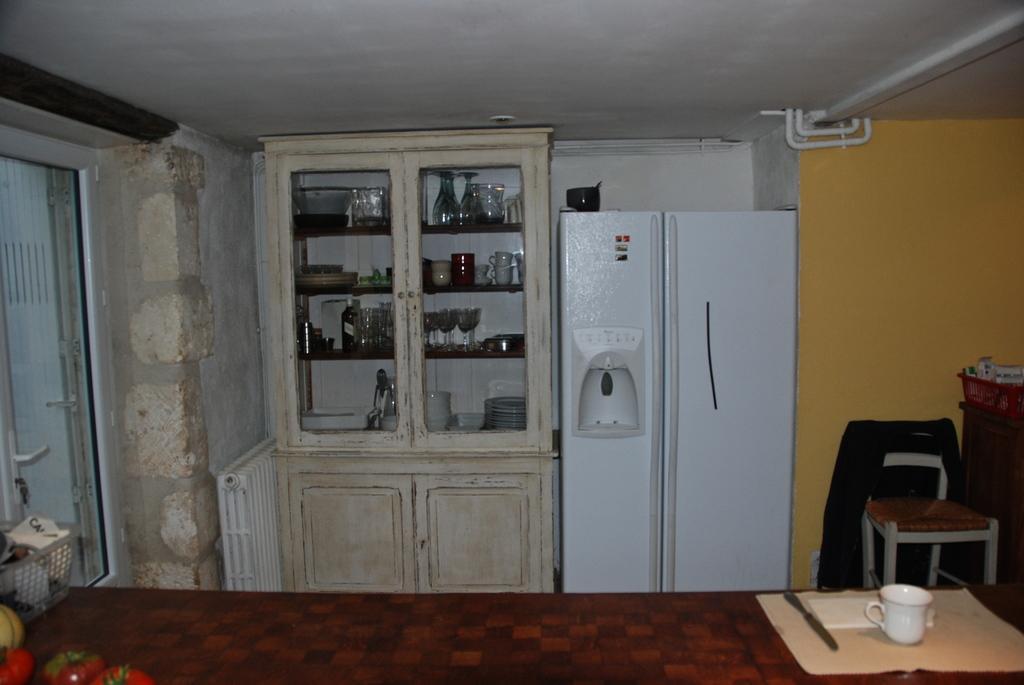Can you describe this image briefly? In this image I can see glasses over here and refrigerator next to it. Here on the table I can see a cup in a plate with knife. In the background I can see a chair and a wall. 